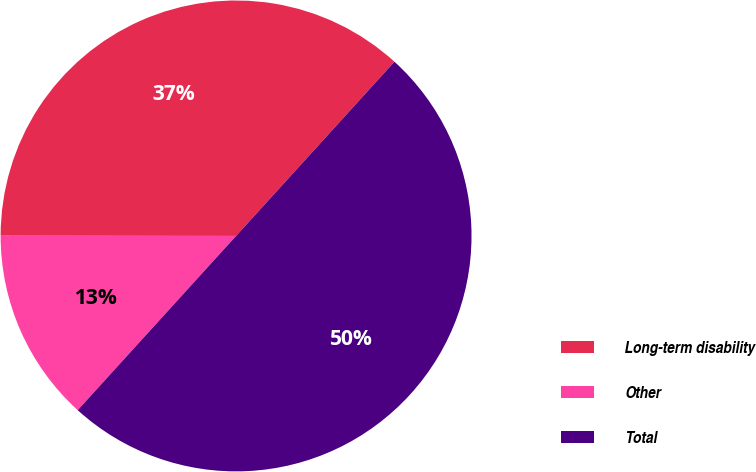Convert chart. <chart><loc_0><loc_0><loc_500><loc_500><pie_chart><fcel>Long-term disability<fcel>Other<fcel>Total<nl><fcel>36.73%<fcel>13.27%<fcel>50.0%<nl></chart> 